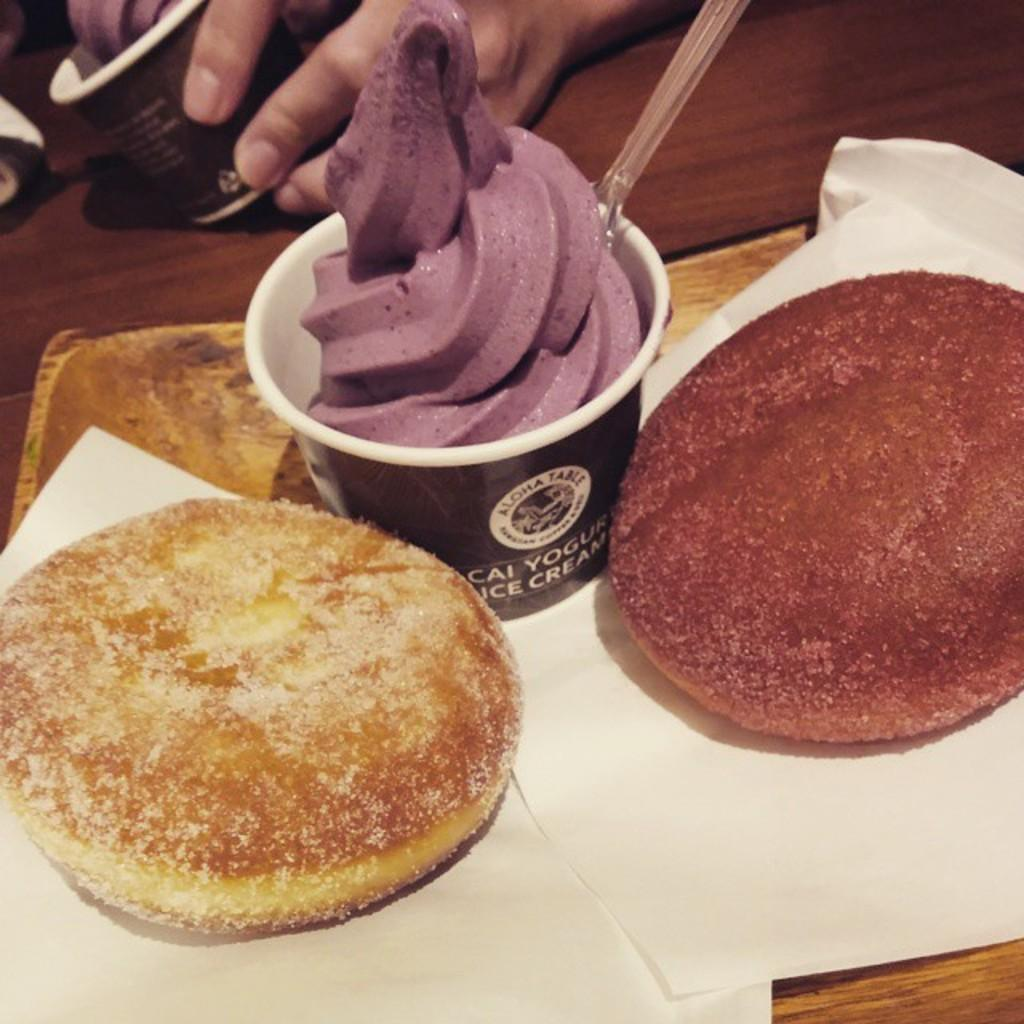What type of objects can be seen in the image related to food? There are food items in the image. What can be used for cleaning or wiping in the image? Tissues are present in the image for cleaning or wiping. What utensil is visible in the image? A spoon is visible in the image. What type of furniture is present in the image? There is a table in the image. Whose hand is visible in the image? A hand of a person is visible in the image. What type of authority figure can be seen in the image? There is no authority figure present in the image. Can you describe the street where the scene in the image takes place? The image does not depict a street; it is focused on food items, tissues, a spoon, a table, and a hand. 